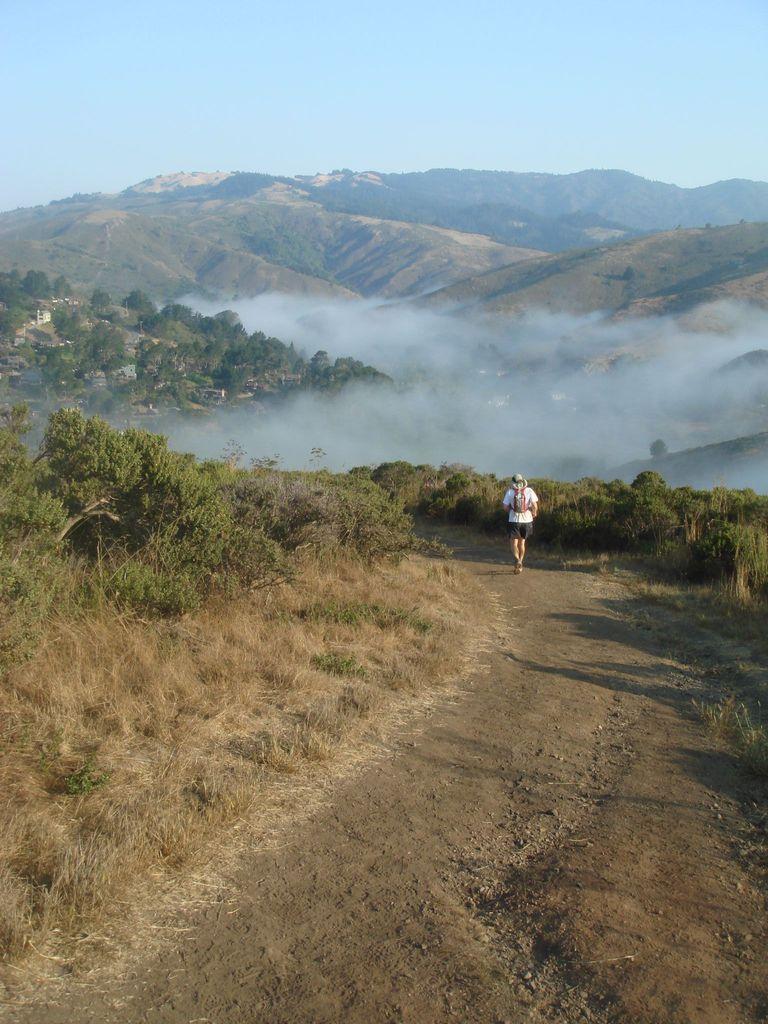Please provide a concise description of this image. In this image there is a person walking, and there are plants, grass, trees, hills, and in the background there is sky. 